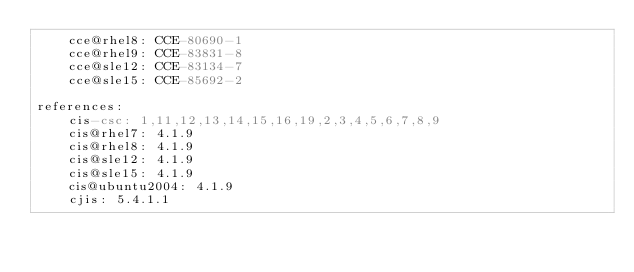Convert code to text. <code><loc_0><loc_0><loc_500><loc_500><_YAML_>    cce@rhel8: CCE-80690-1
    cce@rhel9: CCE-83831-8
    cce@sle12: CCE-83134-7
    cce@sle15: CCE-85692-2

references:
    cis-csc: 1,11,12,13,14,15,16,19,2,3,4,5,6,7,8,9
    cis@rhel7: 4.1.9
    cis@rhel8: 4.1.9
    cis@sle12: 4.1.9
    cis@sle15: 4.1.9
    cis@ubuntu2004: 4.1.9
    cjis: 5.4.1.1</code> 